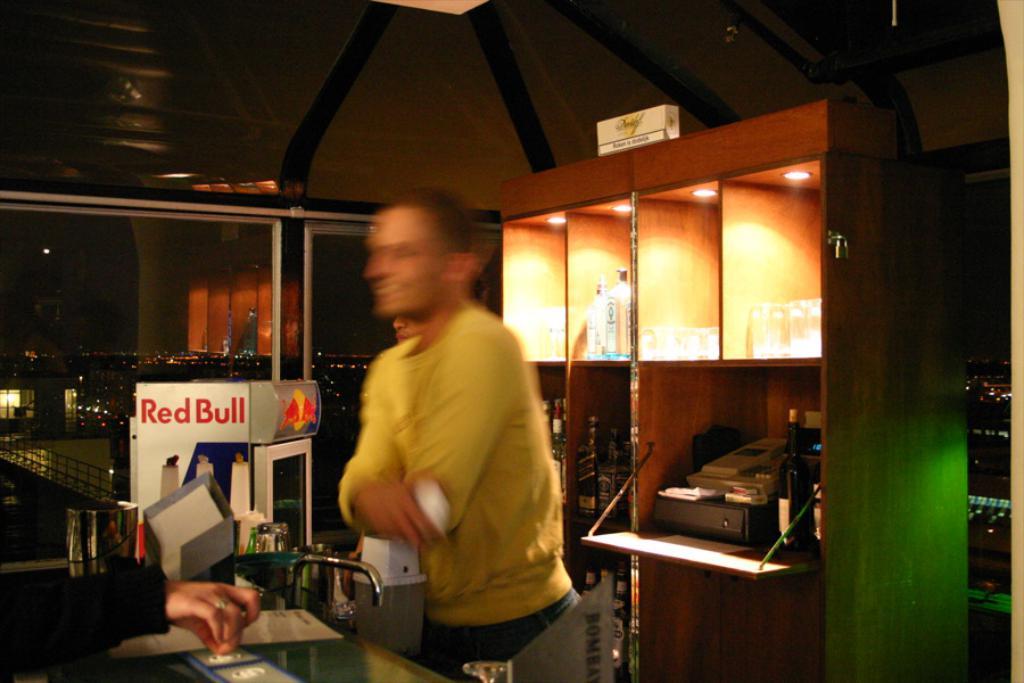What company name is on the machine?
Your answer should be compact. Red bull. 